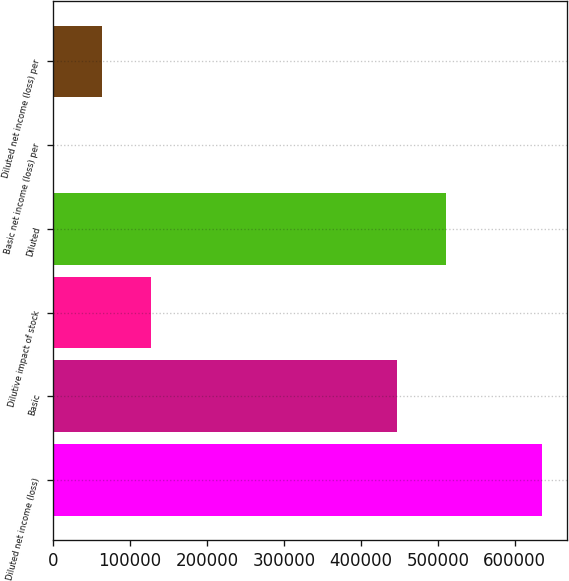Convert chart to OTSL. <chart><loc_0><loc_0><loc_500><loc_500><bar_chart><fcel>Diluted net income (loss)<fcel>Basic<fcel>Dilutive impact of stock<fcel>Diluted<fcel>Basic net income (loss) per<fcel>Diluted net income (loss) per<nl><fcel>635935<fcel>446874<fcel>127188<fcel>510467<fcel>1.42<fcel>63594.8<nl></chart> 